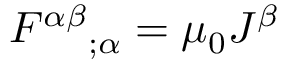<formula> <loc_0><loc_0><loc_500><loc_500>F ^ { \alpha \beta _ { ; \alpha } = \mu _ { 0 } J ^ { \beta }</formula> 